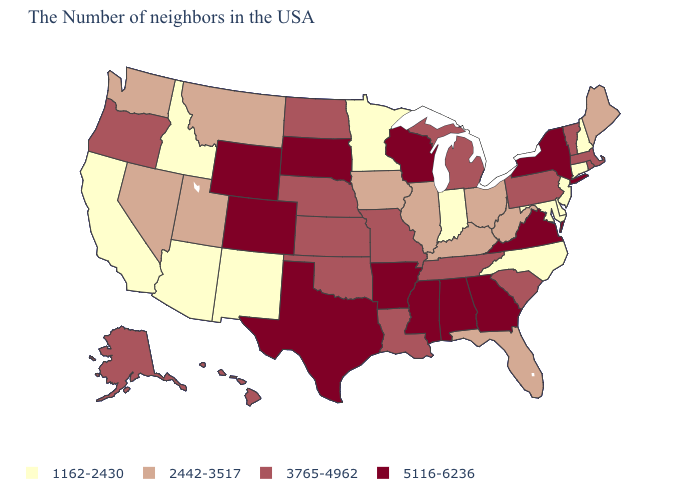Among the states that border New Mexico , does Arizona have the lowest value?
Give a very brief answer. Yes. What is the value of Florida?
Write a very short answer. 2442-3517. What is the value of Nebraska?
Short answer required. 3765-4962. How many symbols are there in the legend?
Write a very short answer. 4. Which states have the lowest value in the USA?
Concise answer only. New Hampshire, Connecticut, New Jersey, Delaware, Maryland, North Carolina, Indiana, Minnesota, New Mexico, Arizona, Idaho, California. What is the highest value in states that border Minnesota?
Concise answer only. 5116-6236. Name the states that have a value in the range 2442-3517?
Write a very short answer. Maine, West Virginia, Ohio, Florida, Kentucky, Illinois, Iowa, Utah, Montana, Nevada, Washington. Does the first symbol in the legend represent the smallest category?
Be succinct. Yes. Which states have the lowest value in the USA?
Keep it brief. New Hampshire, Connecticut, New Jersey, Delaware, Maryland, North Carolina, Indiana, Minnesota, New Mexico, Arizona, Idaho, California. Does Maryland have the same value as Indiana?
Be succinct. Yes. Does Arizona have the lowest value in the West?
Write a very short answer. Yes. Among the states that border Maryland , which have the lowest value?
Short answer required. Delaware. Name the states that have a value in the range 3765-4962?
Be succinct. Massachusetts, Rhode Island, Vermont, Pennsylvania, South Carolina, Michigan, Tennessee, Louisiana, Missouri, Kansas, Nebraska, Oklahoma, North Dakota, Oregon, Alaska, Hawaii. Which states have the lowest value in the USA?
Write a very short answer. New Hampshire, Connecticut, New Jersey, Delaware, Maryland, North Carolina, Indiana, Minnesota, New Mexico, Arizona, Idaho, California. Name the states that have a value in the range 2442-3517?
Answer briefly. Maine, West Virginia, Ohio, Florida, Kentucky, Illinois, Iowa, Utah, Montana, Nevada, Washington. 